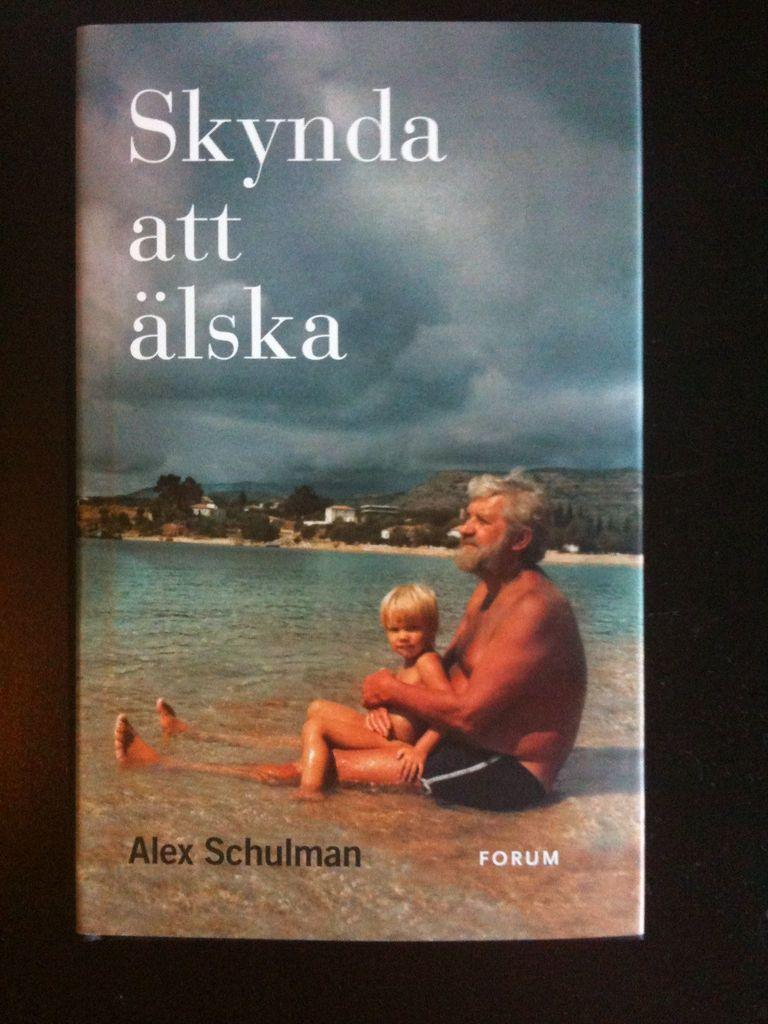<image>
Share a concise interpretation of the image provided. A book cover showing a man holding a child in the sea titled Skyna att alska. 